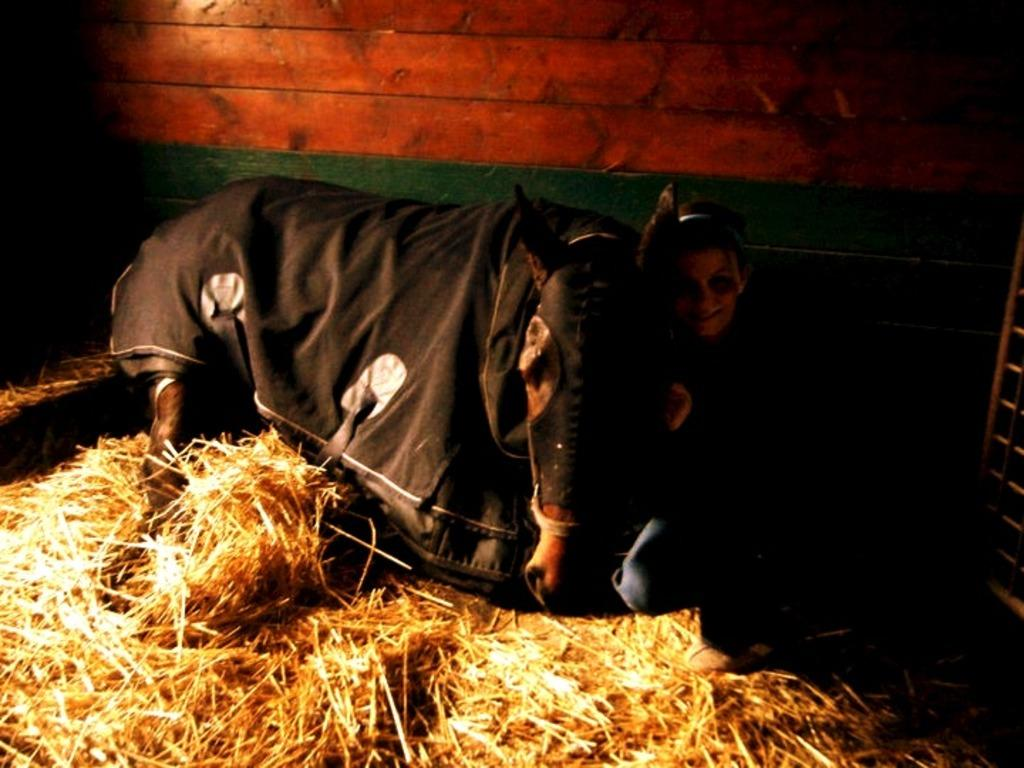Where was the image taken? The image was taken inside a cattle. What can be seen in the foreground of the image? There is a cow laying on the grass in the foreground. Who is present in the image? There is a woman beside the cow in the image. What color is the wall visible in the background? The wall in the background is red. What type of poison is being used to conduct a science experiment in the image? There is no poison or science experiment present in the image. 